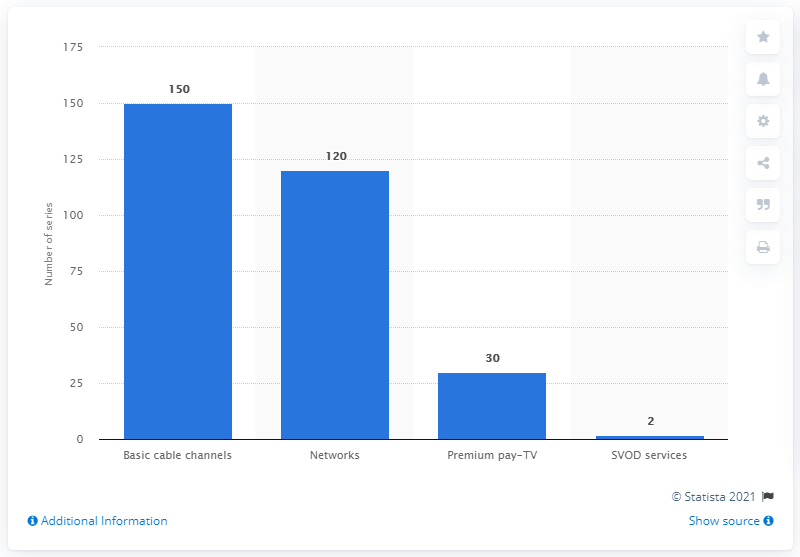Mention a couple of crucial points in this snapshot. In the 2013-2014 television season, a total of 150 episodes of scripted series were produced specifically for basic cable channels in the United States. 